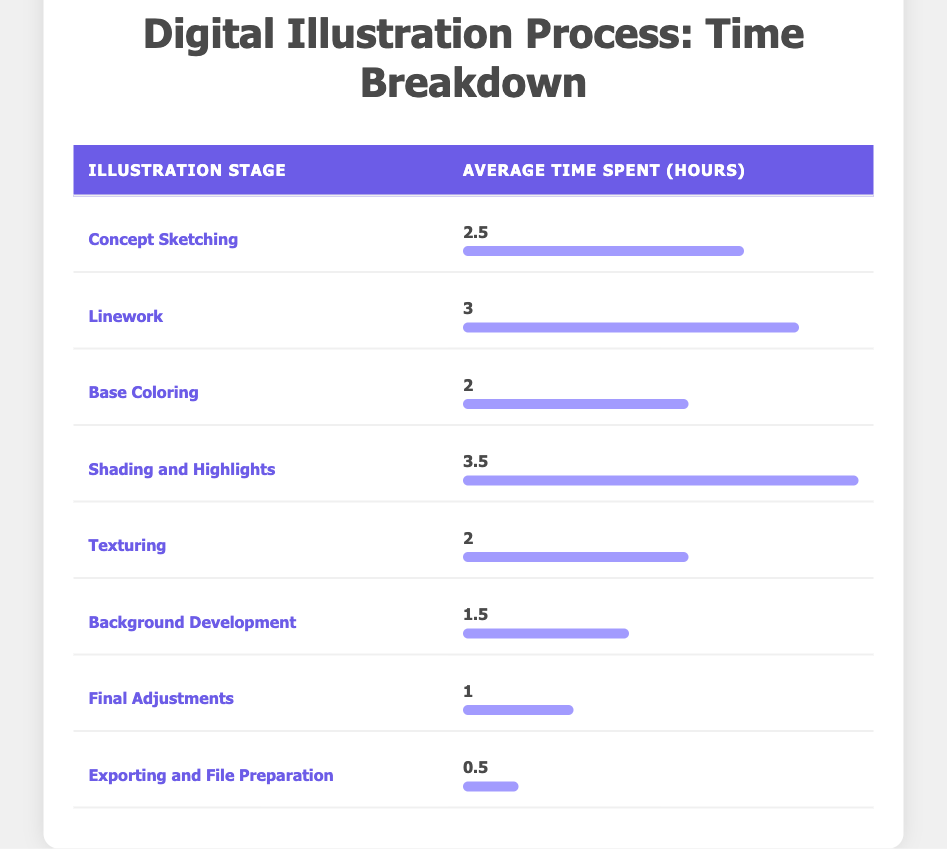What is the average time spent on Shading and Highlights? According to the table, the average time spent on Shading and Highlights is directly stated as 3.5 hours.
Answer: 3.5 hours Which illustration stage takes the least time? From the table, the stage that takes the least time is Exporting and File Preparation, which is 0.5 hours.
Answer: Exporting and File Preparation What is the total time spent on all illustration stages combined? By summing the average times for each stage: 2.5 + 3 + 2 + 3.5 + 2 + 1.5 + 1 + 0.5 = 16 hours. Thus, the total time spent is 16 hours.
Answer: 16 hours Is the average time spent on Background Development greater than the time spent on Texturing? Upon checking the table, Background Development takes 1.5 hours, while Texturing takes 2 hours, making Background Development less than Texturing. Therefore, the statement is false.
Answer: No What are the stages that require more than 3 hours of work? Referring to the table, the stages requiring more than 3 hours are: Linework (3 hours) and Shading and Highlights (3.5 hours). Therefore, these are the stages.
Answer: Linework, Shading and Highlights What is the difference in time between the longest and shortest illustration stages? The longest stage is Shading and Highlights at 3.5 hours and the shortest is Exporting and File Preparation at 0.5 hours. The difference is calculated as 3.5 - 0.5 = 3 hours.
Answer: 3 hours What is the average time spent on the first three stages combined? To find this, add Concept Sketching (2.5 hours), Linework (3 hours), and Base Coloring (2 hours): 2.5 + 3 + 2 = 7.5 hours. Divide by 3 to find the average: 7.5 / 3 = 2.5 hours.
Answer: 2.5 hours How much time is spent on Final Adjustments compared to Background Development? Final Adjustments takes 1 hour, and Background Development takes 1.5 hours. Here, Final Adjustments takes less time than Background Development by 0.5 hours.
Answer: 0.5 hours less Which stage requires the most effort before finalizing the illustration, and how many hours does it take? The stage that requires the most effort is Shading and Highlights, taking 3.5 hours. This is the highest value in the table.
Answer: Shading and Highlights, 3.5 hours 